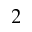Convert formula to latex. <formula><loc_0><loc_0><loc_500><loc_500>_ { 2 }</formula> 